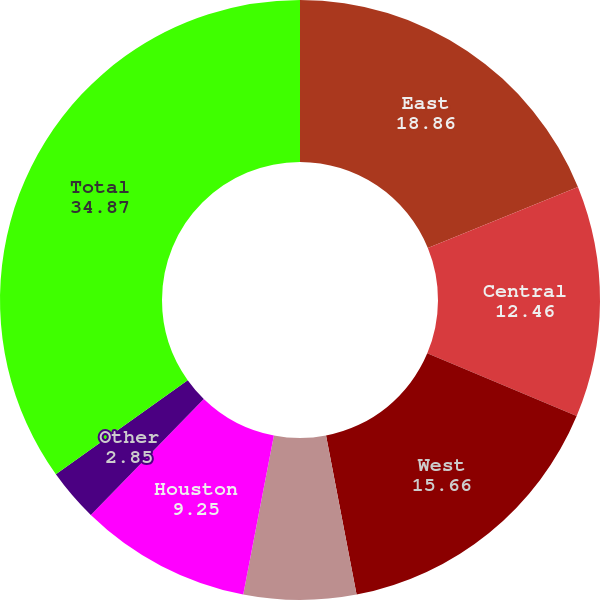Convert chart. <chart><loc_0><loc_0><loc_500><loc_500><pie_chart><fcel>East<fcel>Central<fcel>West<fcel>Southeast Florida<fcel>Houston<fcel>Other<fcel>Total<nl><fcel>18.86%<fcel>12.46%<fcel>15.66%<fcel>6.05%<fcel>9.25%<fcel>2.85%<fcel>34.87%<nl></chart> 